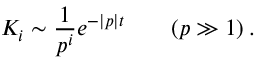Convert formula to latex. <formula><loc_0><loc_0><loc_500><loc_500>K _ { i } \sim \frac { 1 } { p ^ { i } } e ^ { - | p | t } \quad ( p \gg 1 ) \, .</formula> 